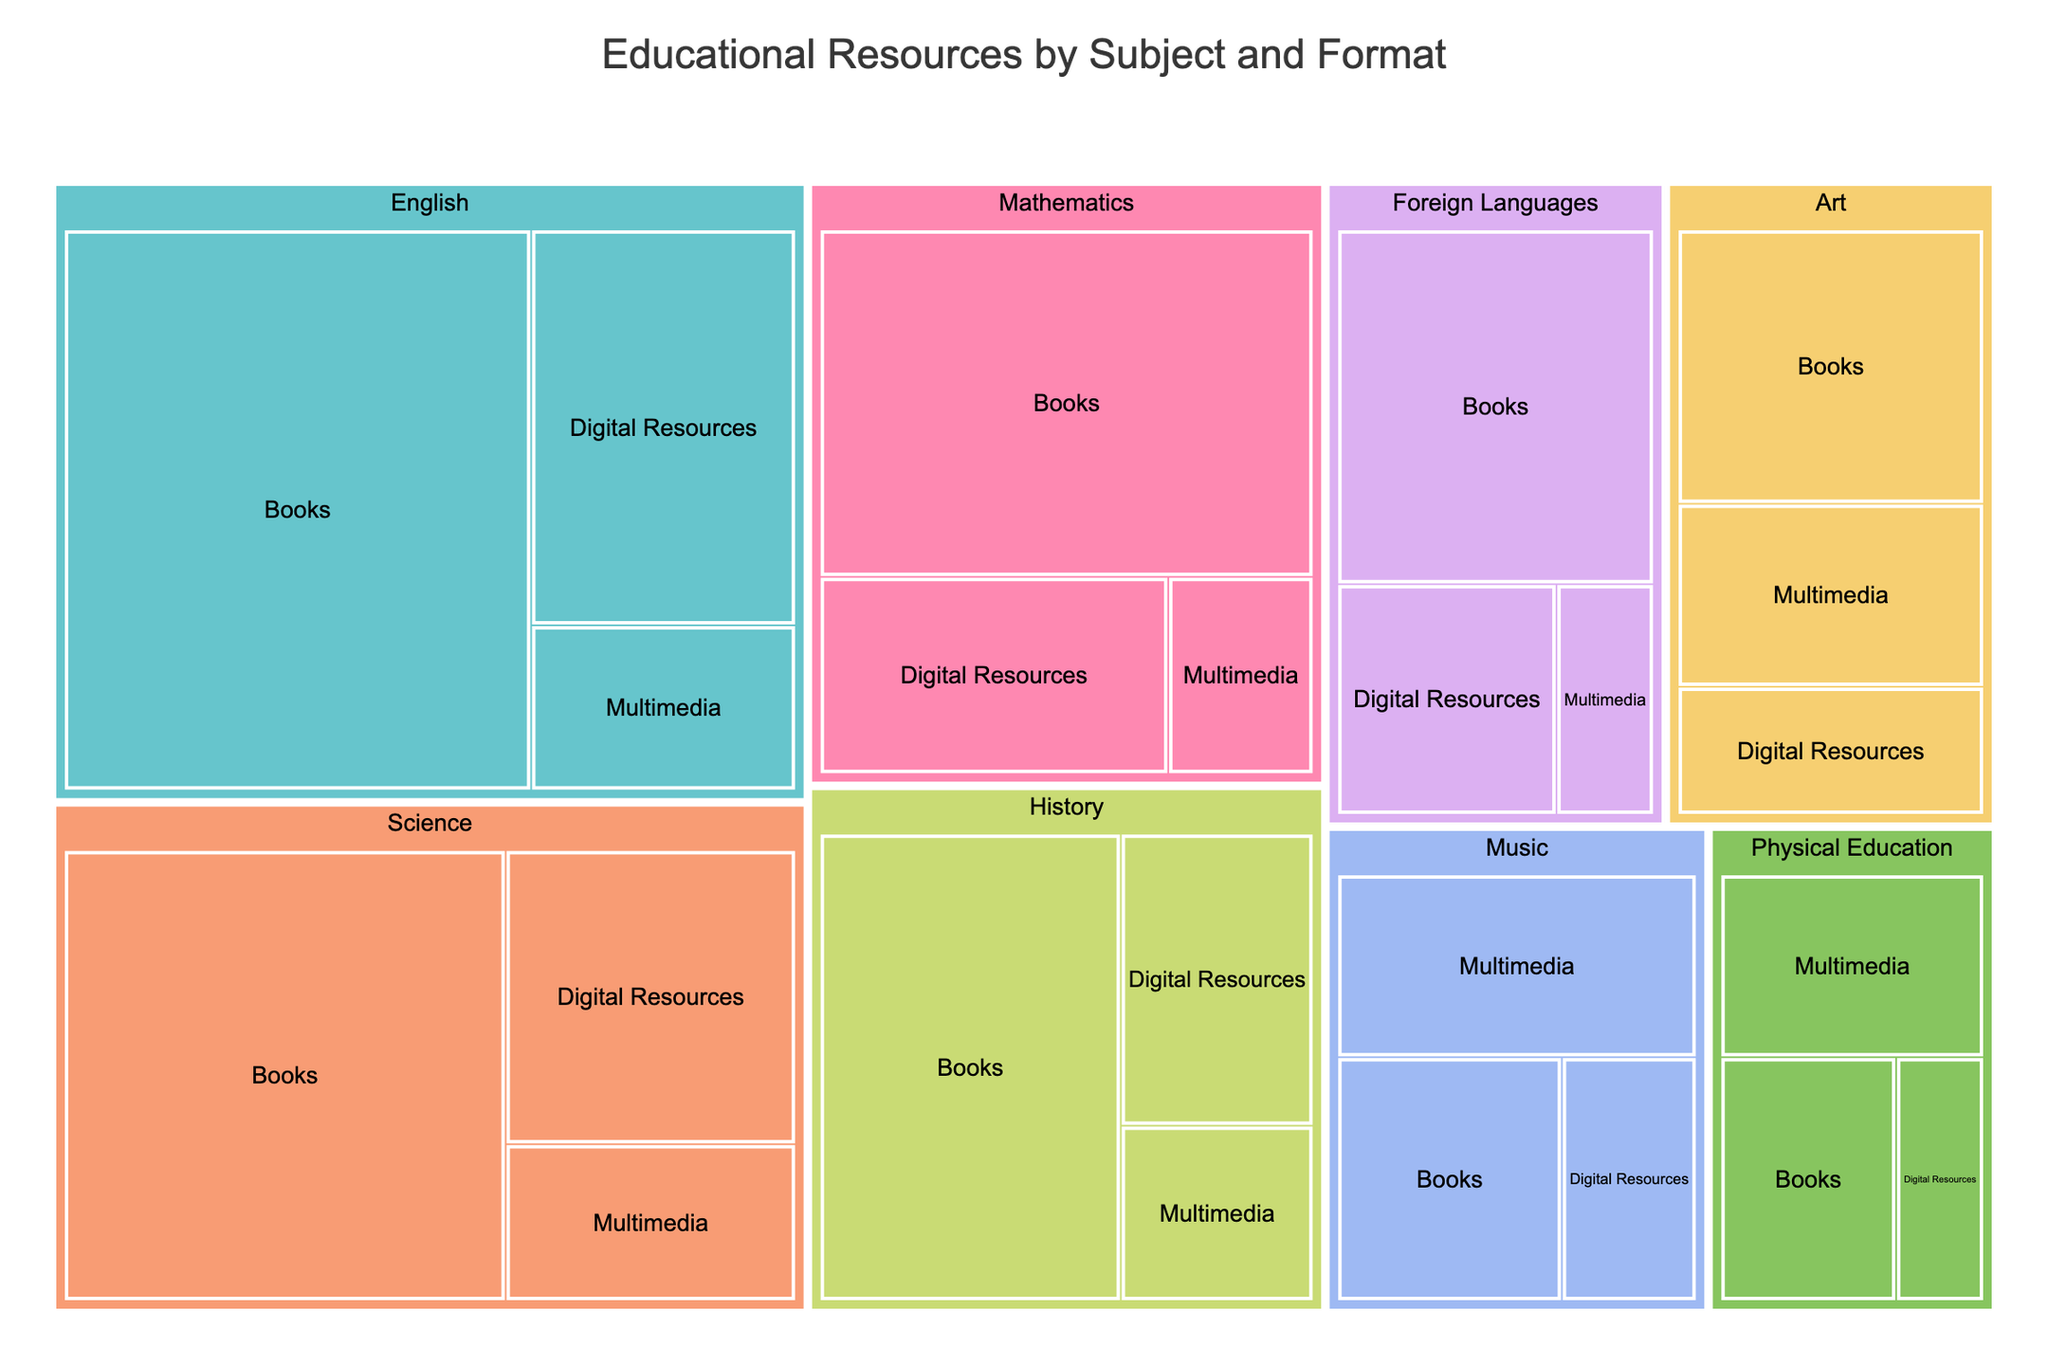What's the title of the figure? The title of the figure can be found at the top and tells us what the figure is about. In this case, it states "Educational Resources by Subject and Format."
Answer: Educational Resources by Subject and Format Which subject has the most books? To find the subject with the most books, look at the part of the treemap labeled "Books" for each subject and compare the quantities. English has 450 books.
Answer: English What is the total quantity of digital resources across all subjects? To find the total quantity of digital resources, add the quantities for each subject under "Digital Resources." 180 (English) + 120 (Mathematics) + 150 (Science) + 100 (History) + 90 (Foreign Languages) + 70 (Art) + 60 (Music) + 40 (Physical Education) = 810.
Answer: 810 How does the quantity of multimedia resources in Art compare to those in Music? Compare the quantities of multimedia resources directly by looking at their respective sections in the treemap. Art has 100 multimedia resources, while Music has 120.
Answer: Music has more multimedia resources than Art Which format has the least representation in Physical Education? To determine this, compare the quantities for Books, Digital Resources, and Multimedia in Physical Education in the treemap. Books have 80, Digital Resources have 40, and Multimedia has 90.
Answer: Digital Resources What is the most common format across all subjects? To identify the most common format, compare the combined total quantities for Books, Digital Resources, and Multimedia. Books: 450 (English) + 300 (Mathematics) + 350 (Science) + 250 (History) + 200 (Foreign Languages) + 150 (Art) + 100 (Music) + 80 (Physical Education) = 1880. Digital Resources: 810 (previously computed). Multimedia: 75 (English) + 50 (Mathematics) + 80 (Science) + 60 (History) + 40 (Foreign Languages) + 100 (Art) + 120 (Music) + 90 (Physical Education) = 615.
Answer: Books What is the ratio of books to digital resources in the English subject area? Look at the quantities of Books and Digital Resources for English. The quantities are 450 and 180 respectively. The ratio is 450:180, which simplifies to 5:2.
Answer: 5:2 Calculate the average quantity of multimedia resources per subject. The total quantity of multimedia resources is 615 (previously computed). There are 8 subjects. Divide the total by the number of subjects: 615 / 8 = 76.875.
Answer: 76.875 Is there any subject where digital resources exceed the quantity of books? Examine each subject's quantities for Books and Digital Resources. None of the subjects have more digital resources than books.
Answer: No Which two subjects have the most similar quantities of digital resources? Compare the quantities of digital resources for each subject to find the two closest values. History has 100, and Foreign Languages has 90, which are the closest to each other.
Answer: History and Foreign Languages 